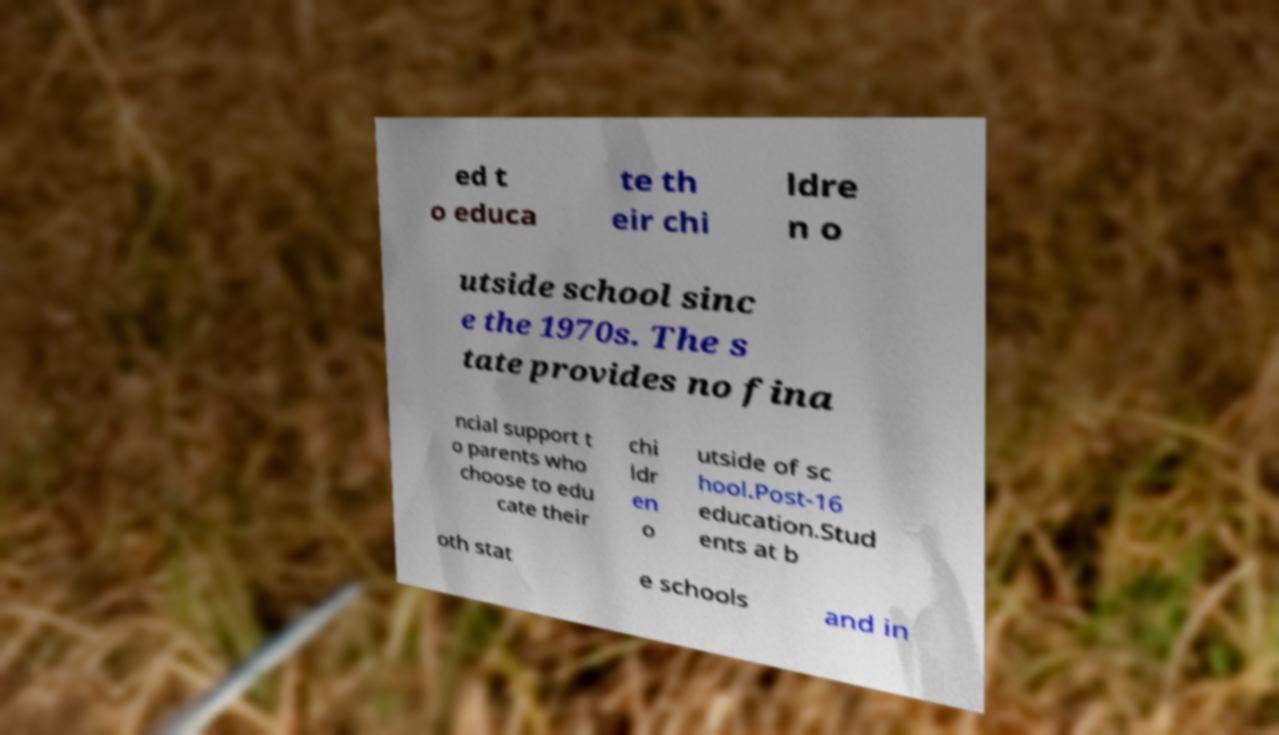For documentation purposes, I need the text within this image transcribed. Could you provide that? ed t o educa te th eir chi ldre n o utside school sinc e the 1970s. The s tate provides no fina ncial support t o parents who choose to edu cate their chi ldr en o utside of sc hool.Post-16 education.Stud ents at b oth stat e schools and in 